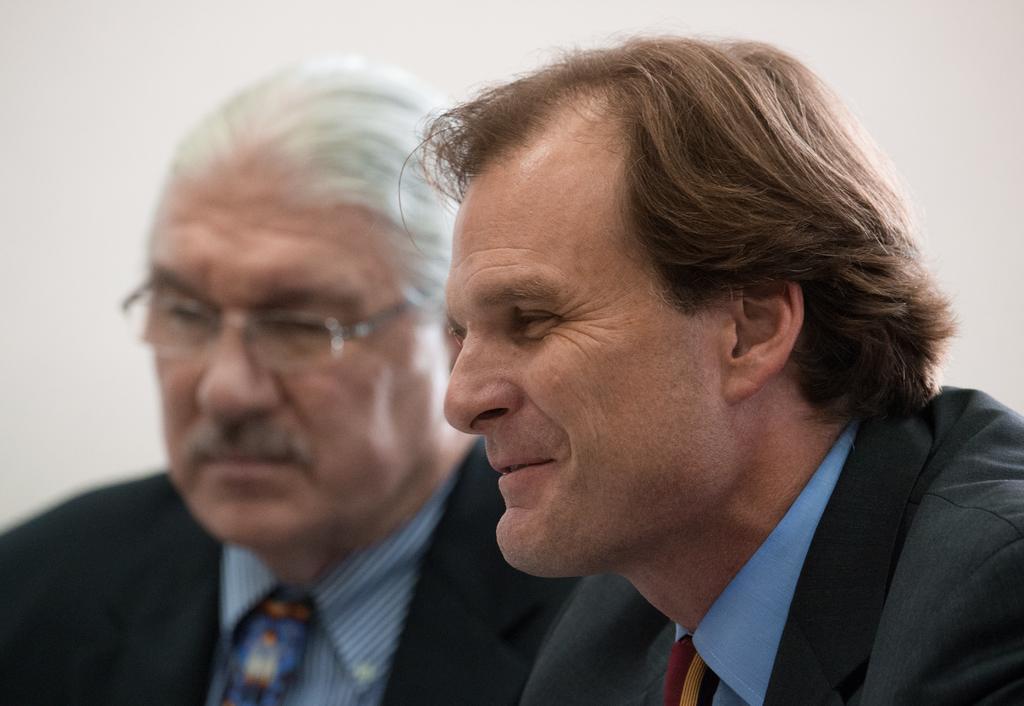In one or two sentences, can you explain what this image depicts? There are two men wearing black color blazer as we can see in the middle of this image and there is a wall in the background. 